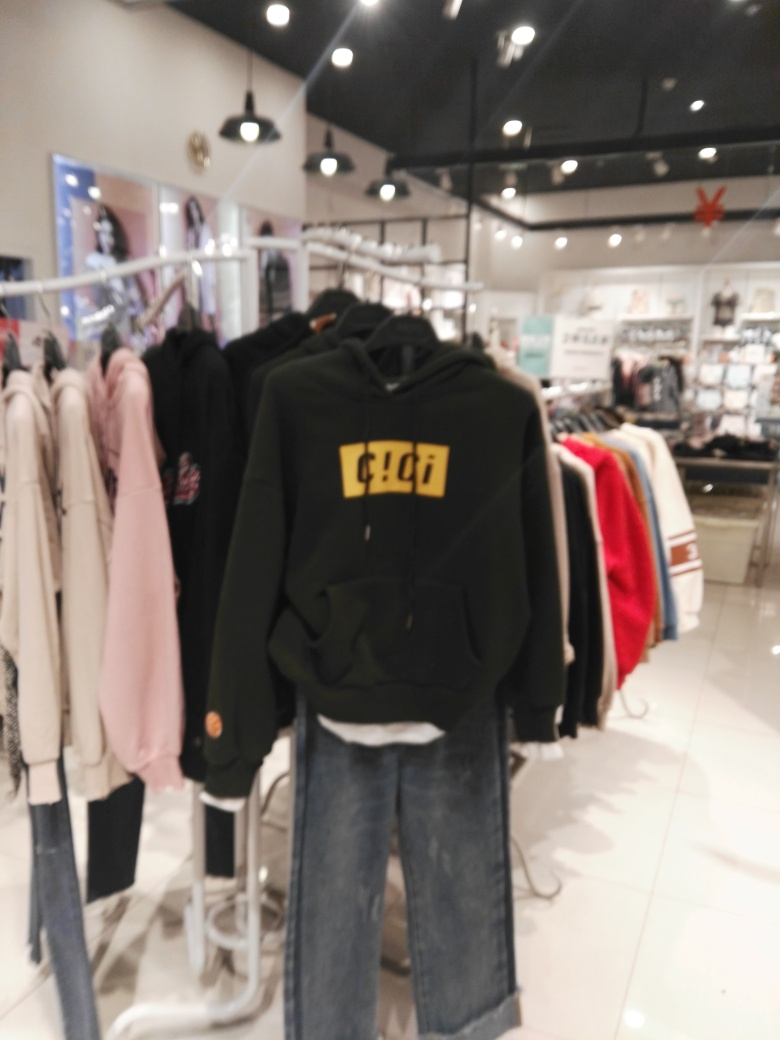The image seems blurry. How can I take better pictures in a store? To improve the quality of pictures taken in a store, ensure your camera's focus is set correctly before taking the shot. Use a higher resolution setting if available. Good lighting is crucial; avoid backlit scenarios and try to use soft, even lighting. Hold the camera steady or use stabilization features to avoid blur. If the store's lighting is inadequate, using a low aperture setting on your camera, if possible, can help capture more light and detail. 